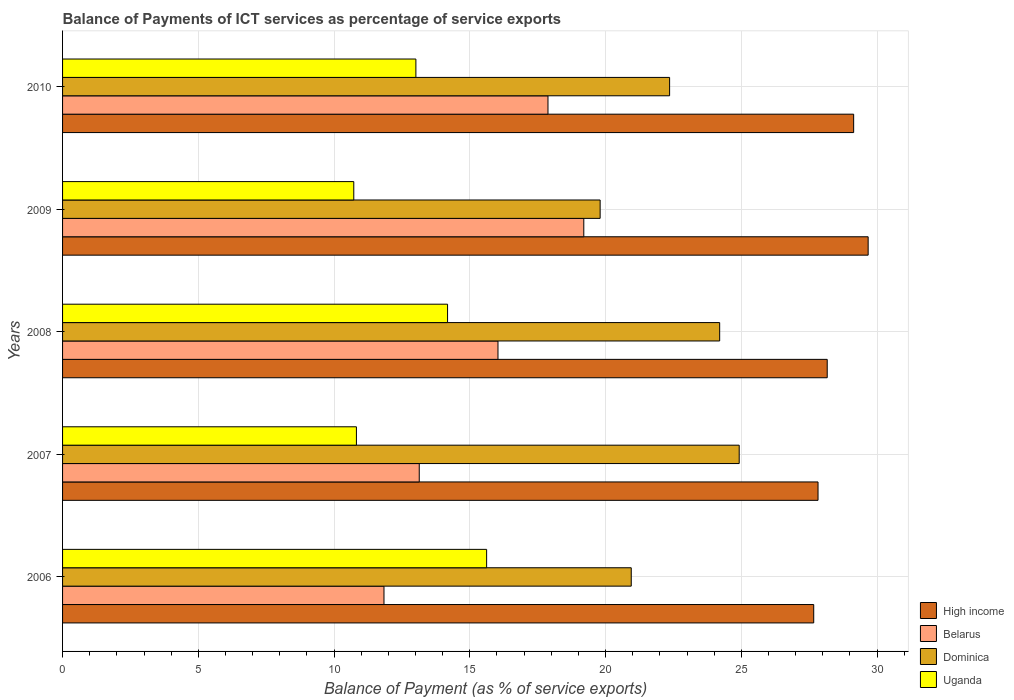Are the number of bars per tick equal to the number of legend labels?
Give a very brief answer. Yes. Are the number of bars on each tick of the Y-axis equal?
Offer a very short reply. Yes. What is the balance of payments of ICT services in Dominica in 2008?
Ensure brevity in your answer.  24.2. Across all years, what is the maximum balance of payments of ICT services in Belarus?
Make the answer very short. 19.2. Across all years, what is the minimum balance of payments of ICT services in Dominica?
Ensure brevity in your answer.  19.8. What is the total balance of payments of ICT services in Dominica in the graph?
Ensure brevity in your answer.  112.23. What is the difference between the balance of payments of ICT services in Dominica in 2006 and that in 2007?
Your response must be concise. -3.98. What is the difference between the balance of payments of ICT services in Uganda in 2009 and the balance of payments of ICT services in Belarus in 2007?
Offer a terse response. -2.41. What is the average balance of payments of ICT services in High income per year?
Offer a very short reply. 28.49. In the year 2009, what is the difference between the balance of payments of ICT services in High income and balance of payments of ICT services in Belarus?
Your answer should be very brief. 10.47. In how many years, is the balance of payments of ICT services in Belarus greater than 29 %?
Provide a short and direct response. 0. What is the ratio of the balance of payments of ICT services in Uganda in 2007 to that in 2008?
Provide a succinct answer. 0.76. Is the difference between the balance of payments of ICT services in High income in 2009 and 2010 greater than the difference between the balance of payments of ICT services in Belarus in 2009 and 2010?
Your answer should be very brief. No. What is the difference between the highest and the second highest balance of payments of ICT services in High income?
Keep it short and to the point. 0.53. What is the difference between the highest and the lowest balance of payments of ICT services in High income?
Offer a terse response. 2. Is the sum of the balance of payments of ICT services in Uganda in 2006 and 2009 greater than the maximum balance of payments of ICT services in Belarus across all years?
Make the answer very short. Yes. What does the 2nd bar from the top in 2009 represents?
Offer a terse response. Dominica. What does the 3rd bar from the bottom in 2010 represents?
Your response must be concise. Dominica. What is the difference between two consecutive major ticks on the X-axis?
Your answer should be very brief. 5. Does the graph contain any zero values?
Make the answer very short. No. Does the graph contain grids?
Your answer should be very brief. Yes. How are the legend labels stacked?
Provide a short and direct response. Vertical. What is the title of the graph?
Offer a very short reply. Balance of Payments of ICT services as percentage of service exports. What is the label or title of the X-axis?
Ensure brevity in your answer.  Balance of Payment (as % of service exports). What is the Balance of Payment (as % of service exports) of High income in 2006?
Offer a terse response. 27.67. What is the Balance of Payment (as % of service exports) of Belarus in 2006?
Ensure brevity in your answer.  11.84. What is the Balance of Payment (as % of service exports) in Dominica in 2006?
Keep it short and to the point. 20.95. What is the Balance of Payment (as % of service exports) in Uganda in 2006?
Provide a short and direct response. 15.62. What is the Balance of Payment (as % of service exports) in High income in 2007?
Your answer should be compact. 27.83. What is the Balance of Payment (as % of service exports) in Belarus in 2007?
Ensure brevity in your answer.  13.14. What is the Balance of Payment (as % of service exports) of Dominica in 2007?
Provide a succinct answer. 24.92. What is the Balance of Payment (as % of service exports) of Uganda in 2007?
Make the answer very short. 10.82. What is the Balance of Payment (as % of service exports) of High income in 2008?
Your response must be concise. 28.16. What is the Balance of Payment (as % of service exports) of Belarus in 2008?
Your answer should be very brief. 16.04. What is the Balance of Payment (as % of service exports) in Dominica in 2008?
Make the answer very short. 24.2. What is the Balance of Payment (as % of service exports) in Uganda in 2008?
Give a very brief answer. 14.18. What is the Balance of Payment (as % of service exports) in High income in 2009?
Your answer should be compact. 29.67. What is the Balance of Payment (as % of service exports) in Belarus in 2009?
Ensure brevity in your answer.  19.2. What is the Balance of Payment (as % of service exports) in Dominica in 2009?
Offer a terse response. 19.8. What is the Balance of Payment (as % of service exports) of Uganda in 2009?
Your answer should be very brief. 10.73. What is the Balance of Payment (as % of service exports) of High income in 2010?
Make the answer very short. 29.14. What is the Balance of Payment (as % of service exports) in Belarus in 2010?
Offer a terse response. 17.88. What is the Balance of Payment (as % of service exports) of Dominica in 2010?
Keep it short and to the point. 22.36. What is the Balance of Payment (as % of service exports) of Uganda in 2010?
Offer a terse response. 13.01. Across all years, what is the maximum Balance of Payment (as % of service exports) in High income?
Make the answer very short. 29.67. Across all years, what is the maximum Balance of Payment (as % of service exports) of Belarus?
Your answer should be very brief. 19.2. Across all years, what is the maximum Balance of Payment (as % of service exports) in Dominica?
Offer a very short reply. 24.92. Across all years, what is the maximum Balance of Payment (as % of service exports) of Uganda?
Your response must be concise. 15.62. Across all years, what is the minimum Balance of Payment (as % of service exports) of High income?
Give a very brief answer. 27.67. Across all years, what is the minimum Balance of Payment (as % of service exports) of Belarus?
Keep it short and to the point. 11.84. Across all years, what is the minimum Balance of Payment (as % of service exports) of Dominica?
Your answer should be very brief. 19.8. Across all years, what is the minimum Balance of Payment (as % of service exports) in Uganda?
Give a very brief answer. 10.73. What is the total Balance of Payment (as % of service exports) in High income in the graph?
Offer a very short reply. 142.47. What is the total Balance of Payment (as % of service exports) in Belarus in the graph?
Keep it short and to the point. 78.09. What is the total Balance of Payment (as % of service exports) of Dominica in the graph?
Your answer should be very brief. 112.23. What is the total Balance of Payment (as % of service exports) in Uganda in the graph?
Offer a terse response. 64.36. What is the difference between the Balance of Payment (as % of service exports) of High income in 2006 and that in 2007?
Your answer should be very brief. -0.16. What is the difference between the Balance of Payment (as % of service exports) of Belarus in 2006 and that in 2007?
Your answer should be compact. -1.3. What is the difference between the Balance of Payment (as % of service exports) of Dominica in 2006 and that in 2007?
Offer a very short reply. -3.98. What is the difference between the Balance of Payment (as % of service exports) of Uganda in 2006 and that in 2007?
Give a very brief answer. 4.8. What is the difference between the Balance of Payment (as % of service exports) in High income in 2006 and that in 2008?
Your answer should be compact. -0.5. What is the difference between the Balance of Payment (as % of service exports) in Belarus in 2006 and that in 2008?
Your answer should be compact. -4.2. What is the difference between the Balance of Payment (as % of service exports) of Dominica in 2006 and that in 2008?
Your response must be concise. -3.26. What is the difference between the Balance of Payment (as % of service exports) in Uganda in 2006 and that in 2008?
Keep it short and to the point. 1.44. What is the difference between the Balance of Payment (as % of service exports) in High income in 2006 and that in 2009?
Ensure brevity in your answer.  -2. What is the difference between the Balance of Payment (as % of service exports) in Belarus in 2006 and that in 2009?
Offer a very short reply. -7.36. What is the difference between the Balance of Payment (as % of service exports) in Dominica in 2006 and that in 2009?
Provide a short and direct response. 1.15. What is the difference between the Balance of Payment (as % of service exports) in Uganda in 2006 and that in 2009?
Offer a very short reply. 4.89. What is the difference between the Balance of Payment (as % of service exports) in High income in 2006 and that in 2010?
Offer a terse response. -1.47. What is the difference between the Balance of Payment (as % of service exports) in Belarus in 2006 and that in 2010?
Offer a very short reply. -6.04. What is the difference between the Balance of Payment (as % of service exports) of Dominica in 2006 and that in 2010?
Keep it short and to the point. -1.41. What is the difference between the Balance of Payment (as % of service exports) in Uganda in 2006 and that in 2010?
Provide a short and direct response. 2.61. What is the difference between the Balance of Payment (as % of service exports) in High income in 2007 and that in 2008?
Offer a very short reply. -0.34. What is the difference between the Balance of Payment (as % of service exports) of Belarus in 2007 and that in 2008?
Offer a terse response. -2.9. What is the difference between the Balance of Payment (as % of service exports) of Dominica in 2007 and that in 2008?
Offer a very short reply. 0.72. What is the difference between the Balance of Payment (as % of service exports) in Uganda in 2007 and that in 2008?
Your response must be concise. -3.36. What is the difference between the Balance of Payment (as % of service exports) in High income in 2007 and that in 2009?
Your answer should be compact. -1.85. What is the difference between the Balance of Payment (as % of service exports) in Belarus in 2007 and that in 2009?
Make the answer very short. -6.06. What is the difference between the Balance of Payment (as % of service exports) of Dominica in 2007 and that in 2009?
Keep it short and to the point. 5.12. What is the difference between the Balance of Payment (as % of service exports) of Uganda in 2007 and that in 2009?
Your answer should be compact. 0.1. What is the difference between the Balance of Payment (as % of service exports) of High income in 2007 and that in 2010?
Keep it short and to the point. -1.31. What is the difference between the Balance of Payment (as % of service exports) in Belarus in 2007 and that in 2010?
Your answer should be very brief. -4.74. What is the difference between the Balance of Payment (as % of service exports) in Dominica in 2007 and that in 2010?
Your answer should be compact. 2.56. What is the difference between the Balance of Payment (as % of service exports) of Uganda in 2007 and that in 2010?
Ensure brevity in your answer.  -2.19. What is the difference between the Balance of Payment (as % of service exports) in High income in 2008 and that in 2009?
Give a very brief answer. -1.51. What is the difference between the Balance of Payment (as % of service exports) of Belarus in 2008 and that in 2009?
Make the answer very short. -3.16. What is the difference between the Balance of Payment (as % of service exports) in Dominica in 2008 and that in 2009?
Give a very brief answer. 4.4. What is the difference between the Balance of Payment (as % of service exports) of Uganda in 2008 and that in 2009?
Ensure brevity in your answer.  3.45. What is the difference between the Balance of Payment (as % of service exports) in High income in 2008 and that in 2010?
Offer a terse response. -0.97. What is the difference between the Balance of Payment (as % of service exports) in Belarus in 2008 and that in 2010?
Offer a very short reply. -1.84. What is the difference between the Balance of Payment (as % of service exports) of Dominica in 2008 and that in 2010?
Offer a terse response. 1.84. What is the difference between the Balance of Payment (as % of service exports) of Uganda in 2008 and that in 2010?
Make the answer very short. 1.17. What is the difference between the Balance of Payment (as % of service exports) in High income in 2009 and that in 2010?
Provide a short and direct response. 0.53. What is the difference between the Balance of Payment (as % of service exports) of Belarus in 2009 and that in 2010?
Your answer should be very brief. 1.32. What is the difference between the Balance of Payment (as % of service exports) in Dominica in 2009 and that in 2010?
Ensure brevity in your answer.  -2.56. What is the difference between the Balance of Payment (as % of service exports) in Uganda in 2009 and that in 2010?
Provide a short and direct response. -2.29. What is the difference between the Balance of Payment (as % of service exports) in High income in 2006 and the Balance of Payment (as % of service exports) in Belarus in 2007?
Ensure brevity in your answer.  14.53. What is the difference between the Balance of Payment (as % of service exports) of High income in 2006 and the Balance of Payment (as % of service exports) of Dominica in 2007?
Give a very brief answer. 2.74. What is the difference between the Balance of Payment (as % of service exports) in High income in 2006 and the Balance of Payment (as % of service exports) in Uganda in 2007?
Provide a succinct answer. 16.84. What is the difference between the Balance of Payment (as % of service exports) in Belarus in 2006 and the Balance of Payment (as % of service exports) in Dominica in 2007?
Provide a short and direct response. -13.08. What is the difference between the Balance of Payment (as % of service exports) of Belarus in 2006 and the Balance of Payment (as % of service exports) of Uganda in 2007?
Your answer should be compact. 1.01. What is the difference between the Balance of Payment (as % of service exports) in Dominica in 2006 and the Balance of Payment (as % of service exports) in Uganda in 2007?
Provide a short and direct response. 10.12. What is the difference between the Balance of Payment (as % of service exports) of High income in 2006 and the Balance of Payment (as % of service exports) of Belarus in 2008?
Provide a short and direct response. 11.63. What is the difference between the Balance of Payment (as % of service exports) of High income in 2006 and the Balance of Payment (as % of service exports) of Dominica in 2008?
Ensure brevity in your answer.  3.46. What is the difference between the Balance of Payment (as % of service exports) of High income in 2006 and the Balance of Payment (as % of service exports) of Uganda in 2008?
Provide a short and direct response. 13.49. What is the difference between the Balance of Payment (as % of service exports) in Belarus in 2006 and the Balance of Payment (as % of service exports) in Dominica in 2008?
Your response must be concise. -12.36. What is the difference between the Balance of Payment (as % of service exports) in Belarus in 2006 and the Balance of Payment (as % of service exports) in Uganda in 2008?
Make the answer very short. -2.34. What is the difference between the Balance of Payment (as % of service exports) of Dominica in 2006 and the Balance of Payment (as % of service exports) of Uganda in 2008?
Make the answer very short. 6.77. What is the difference between the Balance of Payment (as % of service exports) in High income in 2006 and the Balance of Payment (as % of service exports) in Belarus in 2009?
Provide a succinct answer. 8.47. What is the difference between the Balance of Payment (as % of service exports) of High income in 2006 and the Balance of Payment (as % of service exports) of Dominica in 2009?
Offer a terse response. 7.87. What is the difference between the Balance of Payment (as % of service exports) in High income in 2006 and the Balance of Payment (as % of service exports) in Uganda in 2009?
Offer a terse response. 16.94. What is the difference between the Balance of Payment (as % of service exports) of Belarus in 2006 and the Balance of Payment (as % of service exports) of Dominica in 2009?
Your response must be concise. -7.96. What is the difference between the Balance of Payment (as % of service exports) of Belarus in 2006 and the Balance of Payment (as % of service exports) of Uganda in 2009?
Offer a very short reply. 1.11. What is the difference between the Balance of Payment (as % of service exports) in Dominica in 2006 and the Balance of Payment (as % of service exports) in Uganda in 2009?
Provide a succinct answer. 10.22. What is the difference between the Balance of Payment (as % of service exports) of High income in 2006 and the Balance of Payment (as % of service exports) of Belarus in 2010?
Provide a succinct answer. 9.79. What is the difference between the Balance of Payment (as % of service exports) of High income in 2006 and the Balance of Payment (as % of service exports) of Dominica in 2010?
Give a very brief answer. 5.31. What is the difference between the Balance of Payment (as % of service exports) in High income in 2006 and the Balance of Payment (as % of service exports) in Uganda in 2010?
Provide a succinct answer. 14.65. What is the difference between the Balance of Payment (as % of service exports) in Belarus in 2006 and the Balance of Payment (as % of service exports) in Dominica in 2010?
Keep it short and to the point. -10.52. What is the difference between the Balance of Payment (as % of service exports) of Belarus in 2006 and the Balance of Payment (as % of service exports) of Uganda in 2010?
Keep it short and to the point. -1.18. What is the difference between the Balance of Payment (as % of service exports) in Dominica in 2006 and the Balance of Payment (as % of service exports) in Uganda in 2010?
Ensure brevity in your answer.  7.93. What is the difference between the Balance of Payment (as % of service exports) of High income in 2007 and the Balance of Payment (as % of service exports) of Belarus in 2008?
Give a very brief answer. 11.79. What is the difference between the Balance of Payment (as % of service exports) in High income in 2007 and the Balance of Payment (as % of service exports) in Dominica in 2008?
Make the answer very short. 3.62. What is the difference between the Balance of Payment (as % of service exports) in High income in 2007 and the Balance of Payment (as % of service exports) in Uganda in 2008?
Provide a short and direct response. 13.65. What is the difference between the Balance of Payment (as % of service exports) in Belarus in 2007 and the Balance of Payment (as % of service exports) in Dominica in 2008?
Keep it short and to the point. -11.07. What is the difference between the Balance of Payment (as % of service exports) of Belarus in 2007 and the Balance of Payment (as % of service exports) of Uganda in 2008?
Your response must be concise. -1.04. What is the difference between the Balance of Payment (as % of service exports) in Dominica in 2007 and the Balance of Payment (as % of service exports) in Uganda in 2008?
Your response must be concise. 10.74. What is the difference between the Balance of Payment (as % of service exports) in High income in 2007 and the Balance of Payment (as % of service exports) in Belarus in 2009?
Ensure brevity in your answer.  8.63. What is the difference between the Balance of Payment (as % of service exports) of High income in 2007 and the Balance of Payment (as % of service exports) of Dominica in 2009?
Provide a succinct answer. 8.03. What is the difference between the Balance of Payment (as % of service exports) in High income in 2007 and the Balance of Payment (as % of service exports) in Uganda in 2009?
Offer a very short reply. 17.1. What is the difference between the Balance of Payment (as % of service exports) in Belarus in 2007 and the Balance of Payment (as % of service exports) in Dominica in 2009?
Give a very brief answer. -6.66. What is the difference between the Balance of Payment (as % of service exports) in Belarus in 2007 and the Balance of Payment (as % of service exports) in Uganda in 2009?
Offer a very short reply. 2.41. What is the difference between the Balance of Payment (as % of service exports) of Dominica in 2007 and the Balance of Payment (as % of service exports) of Uganda in 2009?
Make the answer very short. 14.2. What is the difference between the Balance of Payment (as % of service exports) of High income in 2007 and the Balance of Payment (as % of service exports) of Belarus in 2010?
Offer a very short reply. 9.95. What is the difference between the Balance of Payment (as % of service exports) in High income in 2007 and the Balance of Payment (as % of service exports) in Dominica in 2010?
Give a very brief answer. 5.47. What is the difference between the Balance of Payment (as % of service exports) in High income in 2007 and the Balance of Payment (as % of service exports) in Uganda in 2010?
Give a very brief answer. 14.81. What is the difference between the Balance of Payment (as % of service exports) in Belarus in 2007 and the Balance of Payment (as % of service exports) in Dominica in 2010?
Give a very brief answer. -9.22. What is the difference between the Balance of Payment (as % of service exports) of Belarus in 2007 and the Balance of Payment (as % of service exports) of Uganda in 2010?
Make the answer very short. 0.12. What is the difference between the Balance of Payment (as % of service exports) in Dominica in 2007 and the Balance of Payment (as % of service exports) in Uganda in 2010?
Your answer should be compact. 11.91. What is the difference between the Balance of Payment (as % of service exports) in High income in 2008 and the Balance of Payment (as % of service exports) in Belarus in 2009?
Give a very brief answer. 8.97. What is the difference between the Balance of Payment (as % of service exports) of High income in 2008 and the Balance of Payment (as % of service exports) of Dominica in 2009?
Provide a succinct answer. 8.36. What is the difference between the Balance of Payment (as % of service exports) of High income in 2008 and the Balance of Payment (as % of service exports) of Uganda in 2009?
Ensure brevity in your answer.  17.44. What is the difference between the Balance of Payment (as % of service exports) of Belarus in 2008 and the Balance of Payment (as % of service exports) of Dominica in 2009?
Keep it short and to the point. -3.76. What is the difference between the Balance of Payment (as % of service exports) of Belarus in 2008 and the Balance of Payment (as % of service exports) of Uganda in 2009?
Keep it short and to the point. 5.31. What is the difference between the Balance of Payment (as % of service exports) of Dominica in 2008 and the Balance of Payment (as % of service exports) of Uganda in 2009?
Your answer should be very brief. 13.48. What is the difference between the Balance of Payment (as % of service exports) of High income in 2008 and the Balance of Payment (as % of service exports) of Belarus in 2010?
Ensure brevity in your answer.  10.28. What is the difference between the Balance of Payment (as % of service exports) in High income in 2008 and the Balance of Payment (as % of service exports) in Dominica in 2010?
Ensure brevity in your answer.  5.81. What is the difference between the Balance of Payment (as % of service exports) of High income in 2008 and the Balance of Payment (as % of service exports) of Uganda in 2010?
Give a very brief answer. 15.15. What is the difference between the Balance of Payment (as % of service exports) of Belarus in 2008 and the Balance of Payment (as % of service exports) of Dominica in 2010?
Provide a short and direct response. -6.32. What is the difference between the Balance of Payment (as % of service exports) in Belarus in 2008 and the Balance of Payment (as % of service exports) in Uganda in 2010?
Keep it short and to the point. 3.02. What is the difference between the Balance of Payment (as % of service exports) in Dominica in 2008 and the Balance of Payment (as % of service exports) in Uganda in 2010?
Your answer should be compact. 11.19. What is the difference between the Balance of Payment (as % of service exports) of High income in 2009 and the Balance of Payment (as % of service exports) of Belarus in 2010?
Provide a short and direct response. 11.79. What is the difference between the Balance of Payment (as % of service exports) in High income in 2009 and the Balance of Payment (as % of service exports) in Dominica in 2010?
Make the answer very short. 7.31. What is the difference between the Balance of Payment (as % of service exports) of High income in 2009 and the Balance of Payment (as % of service exports) of Uganda in 2010?
Your answer should be very brief. 16.66. What is the difference between the Balance of Payment (as % of service exports) in Belarus in 2009 and the Balance of Payment (as % of service exports) in Dominica in 2010?
Your answer should be compact. -3.16. What is the difference between the Balance of Payment (as % of service exports) of Belarus in 2009 and the Balance of Payment (as % of service exports) of Uganda in 2010?
Offer a terse response. 6.18. What is the difference between the Balance of Payment (as % of service exports) in Dominica in 2009 and the Balance of Payment (as % of service exports) in Uganda in 2010?
Keep it short and to the point. 6.79. What is the average Balance of Payment (as % of service exports) in High income per year?
Keep it short and to the point. 28.49. What is the average Balance of Payment (as % of service exports) in Belarus per year?
Make the answer very short. 15.62. What is the average Balance of Payment (as % of service exports) of Dominica per year?
Your answer should be very brief. 22.45. What is the average Balance of Payment (as % of service exports) of Uganda per year?
Make the answer very short. 12.87. In the year 2006, what is the difference between the Balance of Payment (as % of service exports) of High income and Balance of Payment (as % of service exports) of Belarus?
Offer a terse response. 15.83. In the year 2006, what is the difference between the Balance of Payment (as % of service exports) in High income and Balance of Payment (as % of service exports) in Dominica?
Provide a succinct answer. 6.72. In the year 2006, what is the difference between the Balance of Payment (as % of service exports) of High income and Balance of Payment (as % of service exports) of Uganda?
Make the answer very short. 12.05. In the year 2006, what is the difference between the Balance of Payment (as % of service exports) of Belarus and Balance of Payment (as % of service exports) of Dominica?
Your answer should be compact. -9.11. In the year 2006, what is the difference between the Balance of Payment (as % of service exports) of Belarus and Balance of Payment (as % of service exports) of Uganda?
Provide a short and direct response. -3.78. In the year 2006, what is the difference between the Balance of Payment (as % of service exports) in Dominica and Balance of Payment (as % of service exports) in Uganda?
Offer a terse response. 5.33. In the year 2007, what is the difference between the Balance of Payment (as % of service exports) in High income and Balance of Payment (as % of service exports) in Belarus?
Your answer should be compact. 14.69. In the year 2007, what is the difference between the Balance of Payment (as % of service exports) of High income and Balance of Payment (as % of service exports) of Dominica?
Your answer should be very brief. 2.9. In the year 2007, what is the difference between the Balance of Payment (as % of service exports) in High income and Balance of Payment (as % of service exports) in Uganda?
Give a very brief answer. 17. In the year 2007, what is the difference between the Balance of Payment (as % of service exports) in Belarus and Balance of Payment (as % of service exports) in Dominica?
Provide a short and direct response. -11.78. In the year 2007, what is the difference between the Balance of Payment (as % of service exports) in Belarus and Balance of Payment (as % of service exports) in Uganda?
Provide a short and direct response. 2.31. In the year 2007, what is the difference between the Balance of Payment (as % of service exports) in Dominica and Balance of Payment (as % of service exports) in Uganda?
Your response must be concise. 14.1. In the year 2008, what is the difference between the Balance of Payment (as % of service exports) of High income and Balance of Payment (as % of service exports) of Belarus?
Ensure brevity in your answer.  12.13. In the year 2008, what is the difference between the Balance of Payment (as % of service exports) in High income and Balance of Payment (as % of service exports) in Dominica?
Your answer should be compact. 3.96. In the year 2008, what is the difference between the Balance of Payment (as % of service exports) in High income and Balance of Payment (as % of service exports) in Uganda?
Your answer should be compact. 13.98. In the year 2008, what is the difference between the Balance of Payment (as % of service exports) of Belarus and Balance of Payment (as % of service exports) of Dominica?
Give a very brief answer. -8.16. In the year 2008, what is the difference between the Balance of Payment (as % of service exports) of Belarus and Balance of Payment (as % of service exports) of Uganda?
Provide a short and direct response. 1.86. In the year 2008, what is the difference between the Balance of Payment (as % of service exports) in Dominica and Balance of Payment (as % of service exports) in Uganda?
Provide a succinct answer. 10.02. In the year 2009, what is the difference between the Balance of Payment (as % of service exports) of High income and Balance of Payment (as % of service exports) of Belarus?
Your answer should be compact. 10.47. In the year 2009, what is the difference between the Balance of Payment (as % of service exports) of High income and Balance of Payment (as % of service exports) of Dominica?
Provide a short and direct response. 9.87. In the year 2009, what is the difference between the Balance of Payment (as % of service exports) of High income and Balance of Payment (as % of service exports) of Uganda?
Your answer should be compact. 18.95. In the year 2009, what is the difference between the Balance of Payment (as % of service exports) in Belarus and Balance of Payment (as % of service exports) in Dominica?
Your answer should be very brief. -0.6. In the year 2009, what is the difference between the Balance of Payment (as % of service exports) in Belarus and Balance of Payment (as % of service exports) in Uganda?
Give a very brief answer. 8.47. In the year 2009, what is the difference between the Balance of Payment (as % of service exports) of Dominica and Balance of Payment (as % of service exports) of Uganda?
Your answer should be compact. 9.07. In the year 2010, what is the difference between the Balance of Payment (as % of service exports) in High income and Balance of Payment (as % of service exports) in Belarus?
Provide a short and direct response. 11.26. In the year 2010, what is the difference between the Balance of Payment (as % of service exports) in High income and Balance of Payment (as % of service exports) in Dominica?
Provide a succinct answer. 6.78. In the year 2010, what is the difference between the Balance of Payment (as % of service exports) of High income and Balance of Payment (as % of service exports) of Uganda?
Keep it short and to the point. 16.12. In the year 2010, what is the difference between the Balance of Payment (as % of service exports) of Belarus and Balance of Payment (as % of service exports) of Dominica?
Provide a short and direct response. -4.48. In the year 2010, what is the difference between the Balance of Payment (as % of service exports) in Belarus and Balance of Payment (as % of service exports) in Uganda?
Your answer should be very brief. 4.87. In the year 2010, what is the difference between the Balance of Payment (as % of service exports) of Dominica and Balance of Payment (as % of service exports) of Uganda?
Make the answer very short. 9.35. What is the ratio of the Balance of Payment (as % of service exports) in Belarus in 2006 to that in 2007?
Your answer should be compact. 0.9. What is the ratio of the Balance of Payment (as % of service exports) of Dominica in 2006 to that in 2007?
Make the answer very short. 0.84. What is the ratio of the Balance of Payment (as % of service exports) in Uganda in 2006 to that in 2007?
Offer a terse response. 1.44. What is the ratio of the Balance of Payment (as % of service exports) of High income in 2006 to that in 2008?
Your answer should be very brief. 0.98. What is the ratio of the Balance of Payment (as % of service exports) of Belarus in 2006 to that in 2008?
Offer a terse response. 0.74. What is the ratio of the Balance of Payment (as % of service exports) of Dominica in 2006 to that in 2008?
Provide a succinct answer. 0.87. What is the ratio of the Balance of Payment (as % of service exports) in Uganda in 2006 to that in 2008?
Offer a terse response. 1.1. What is the ratio of the Balance of Payment (as % of service exports) in High income in 2006 to that in 2009?
Give a very brief answer. 0.93. What is the ratio of the Balance of Payment (as % of service exports) in Belarus in 2006 to that in 2009?
Offer a terse response. 0.62. What is the ratio of the Balance of Payment (as % of service exports) of Dominica in 2006 to that in 2009?
Provide a short and direct response. 1.06. What is the ratio of the Balance of Payment (as % of service exports) in Uganda in 2006 to that in 2009?
Make the answer very short. 1.46. What is the ratio of the Balance of Payment (as % of service exports) in High income in 2006 to that in 2010?
Provide a short and direct response. 0.95. What is the ratio of the Balance of Payment (as % of service exports) in Belarus in 2006 to that in 2010?
Your answer should be very brief. 0.66. What is the ratio of the Balance of Payment (as % of service exports) of Dominica in 2006 to that in 2010?
Offer a very short reply. 0.94. What is the ratio of the Balance of Payment (as % of service exports) in Uganda in 2006 to that in 2010?
Ensure brevity in your answer.  1.2. What is the ratio of the Balance of Payment (as % of service exports) in High income in 2007 to that in 2008?
Provide a succinct answer. 0.99. What is the ratio of the Balance of Payment (as % of service exports) of Belarus in 2007 to that in 2008?
Offer a very short reply. 0.82. What is the ratio of the Balance of Payment (as % of service exports) in Dominica in 2007 to that in 2008?
Your answer should be compact. 1.03. What is the ratio of the Balance of Payment (as % of service exports) in Uganda in 2007 to that in 2008?
Provide a short and direct response. 0.76. What is the ratio of the Balance of Payment (as % of service exports) of High income in 2007 to that in 2009?
Offer a terse response. 0.94. What is the ratio of the Balance of Payment (as % of service exports) of Belarus in 2007 to that in 2009?
Your response must be concise. 0.68. What is the ratio of the Balance of Payment (as % of service exports) of Dominica in 2007 to that in 2009?
Ensure brevity in your answer.  1.26. What is the ratio of the Balance of Payment (as % of service exports) of Uganda in 2007 to that in 2009?
Offer a terse response. 1.01. What is the ratio of the Balance of Payment (as % of service exports) of High income in 2007 to that in 2010?
Ensure brevity in your answer.  0.95. What is the ratio of the Balance of Payment (as % of service exports) in Belarus in 2007 to that in 2010?
Offer a very short reply. 0.73. What is the ratio of the Balance of Payment (as % of service exports) in Dominica in 2007 to that in 2010?
Offer a terse response. 1.11. What is the ratio of the Balance of Payment (as % of service exports) in Uganda in 2007 to that in 2010?
Offer a very short reply. 0.83. What is the ratio of the Balance of Payment (as % of service exports) in High income in 2008 to that in 2009?
Offer a terse response. 0.95. What is the ratio of the Balance of Payment (as % of service exports) in Belarus in 2008 to that in 2009?
Keep it short and to the point. 0.84. What is the ratio of the Balance of Payment (as % of service exports) in Dominica in 2008 to that in 2009?
Your response must be concise. 1.22. What is the ratio of the Balance of Payment (as % of service exports) in Uganda in 2008 to that in 2009?
Ensure brevity in your answer.  1.32. What is the ratio of the Balance of Payment (as % of service exports) in High income in 2008 to that in 2010?
Provide a succinct answer. 0.97. What is the ratio of the Balance of Payment (as % of service exports) of Belarus in 2008 to that in 2010?
Ensure brevity in your answer.  0.9. What is the ratio of the Balance of Payment (as % of service exports) of Dominica in 2008 to that in 2010?
Your answer should be very brief. 1.08. What is the ratio of the Balance of Payment (as % of service exports) of Uganda in 2008 to that in 2010?
Offer a very short reply. 1.09. What is the ratio of the Balance of Payment (as % of service exports) in High income in 2009 to that in 2010?
Your answer should be compact. 1.02. What is the ratio of the Balance of Payment (as % of service exports) of Belarus in 2009 to that in 2010?
Ensure brevity in your answer.  1.07. What is the ratio of the Balance of Payment (as % of service exports) in Dominica in 2009 to that in 2010?
Give a very brief answer. 0.89. What is the ratio of the Balance of Payment (as % of service exports) of Uganda in 2009 to that in 2010?
Ensure brevity in your answer.  0.82. What is the difference between the highest and the second highest Balance of Payment (as % of service exports) of High income?
Your answer should be very brief. 0.53. What is the difference between the highest and the second highest Balance of Payment (as % of service exports) of Belarus?
Provide a short and direct response. 1.32. What is the difference between the highest and the second highest Balance of Payment (as % of service exports) in Dominica?
Make the answer very short. 0.72. What is the difference between the highest and the second highest Balance of Payment (as % of service exports) in Uganda?
Your answer should be very brief. 1.44. What is the difference between the highest and the lowest Balance of Payment (as % of service exports) of High income?
Provide a succinct answer. 2. What is the difference between the highest and the lowest Balance of Payment (as % of service exports) of Belarus?
Ensure brevity in your answer.  7.36. What is the difference between the highest and the lowest Balance of Payment (as % of service exports) of Dominica?
Your answer should be very brief. 5.12. What is the difference between the highest and the lowest Balance of Payment (as % of service exports) in Uganda?
Give a very brief answer. 4.89. 